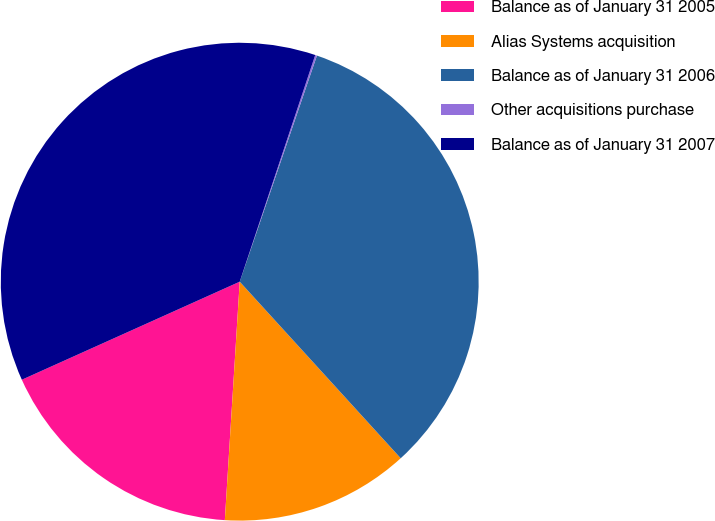Convert chart to OTSL. <chart><loc_0><loc_0><loc_500><loc_500><pie_chart><fcel>Balance as of January 31 2005<fcel>Alias Systems acquisition<fcel>Balance as of January 31 2006<fcel>Other acquisitions purchase<fcel>Balance as of January 31 2007<nl><fcel>17.28%<fcel>12.76%<fcel>33.0%<fcel>0.12%<fcel>36.85%<nl></chart> 